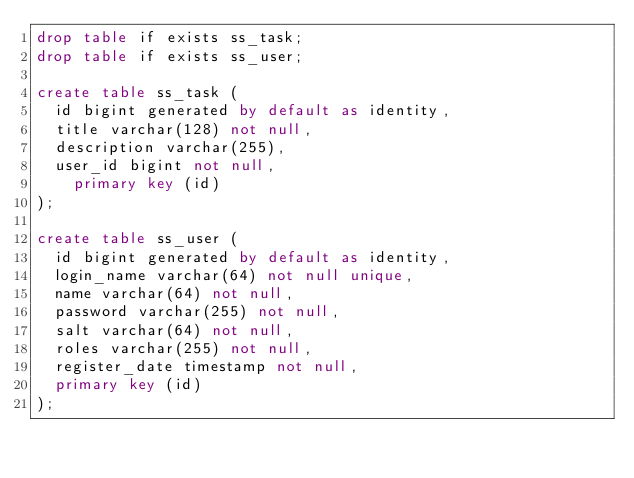<code> <loc_0><loc_0><loc_500><loc_500><_SQL_>drop table if exists ss_task;
drop table if exists ss_user;

create table ss_task (
	id bigint generated by default as identity,
	title varchar(128) not null,
	description varchar(255),
	user_id bigint not null,
    primary key (id)
);

create table ss_user (
	id bigint generated by default as identity,
	login_name varchar(64) not null unique,
	name varchar(64) not null,
	password varchar(255) not null,
	salt varchar(64) not null,
	roles varchar(255) not null,
	register_date timestamp not null,
	primary key (id)
);</code> 